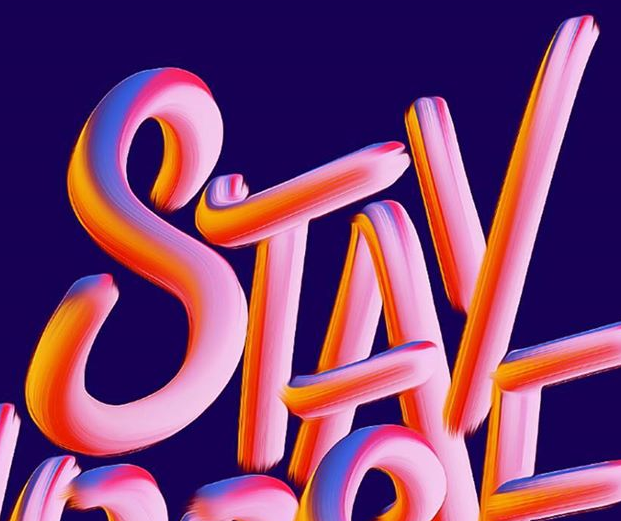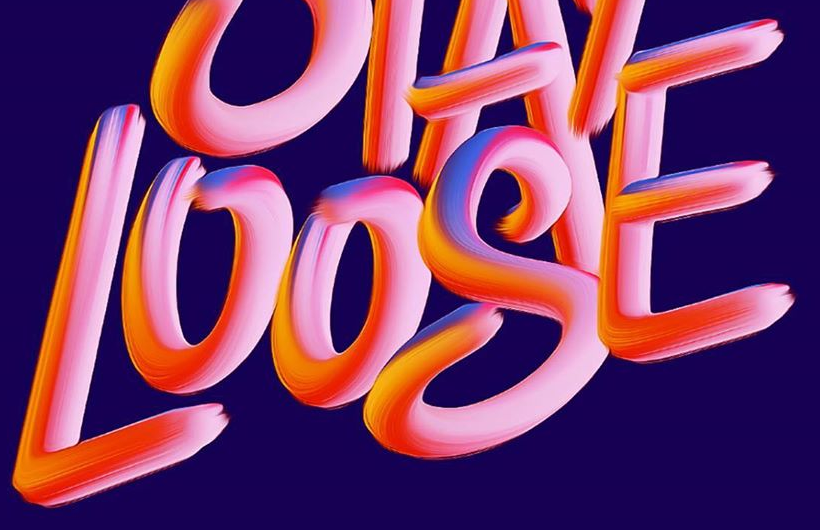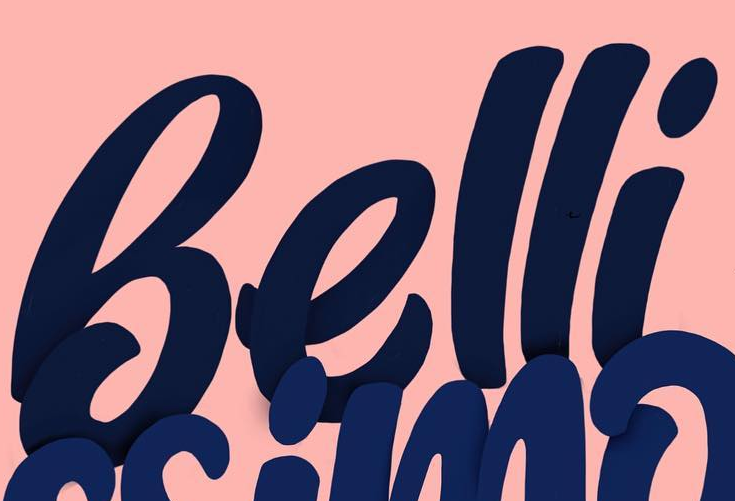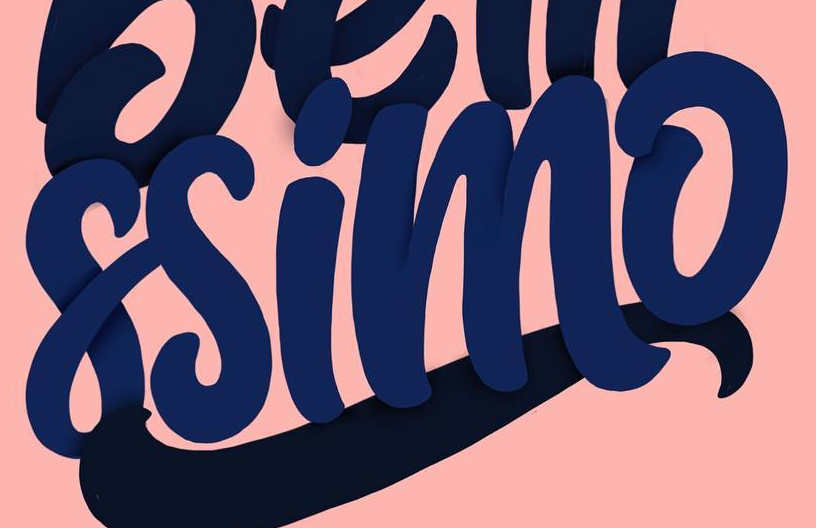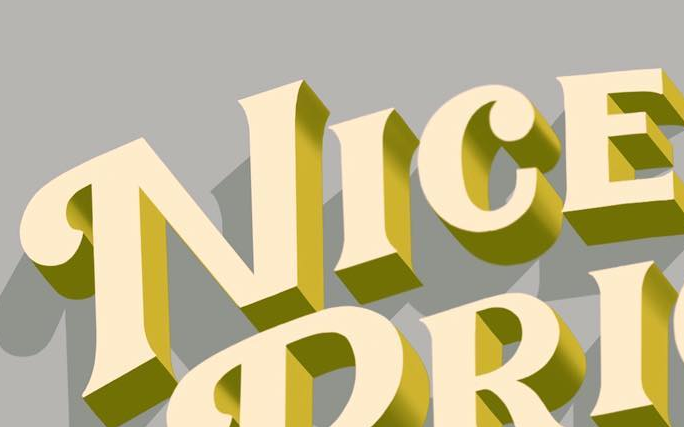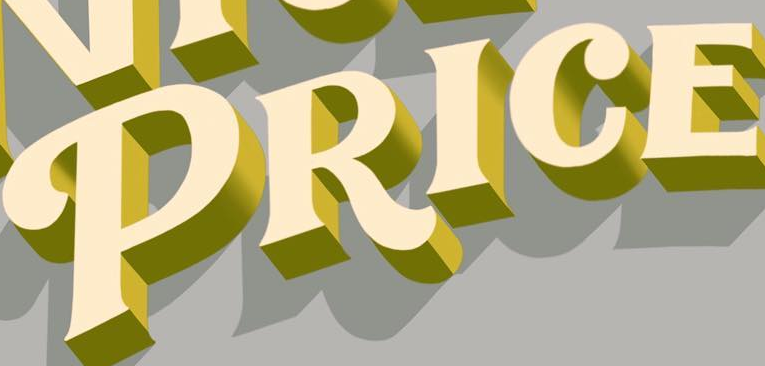What words can you see in these images in sequence, separated by a semicolon? STAY; LOOSE; Belli; ssimo; NICE; PRICE 